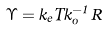Convert formula to latex. <formula><loc_0><loc_0><loc_500><loc_500>\Upsilon = k _ { e } T k _ { o } ^ { - 1 } R</formula> 